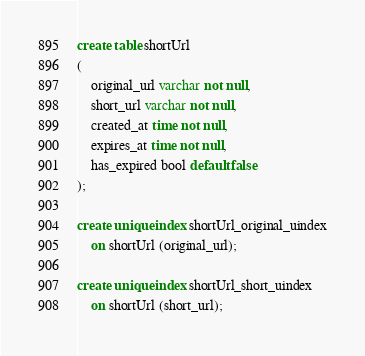Convert code to text. <code><loc_0><loc_0><loc_500><loc_500><_SQL_>create table shortUrl
(
    original_url varchar not null,
    short_url varchar not null,
    created_at time not null,
    expires_at time not null,
    has_expired bool default false
);

create unique index shortUrl_original_uindex
    on shortUrl (original_url);

create unique index shortUrl_short_uindex
    on shortUrl (short_url);</code> 